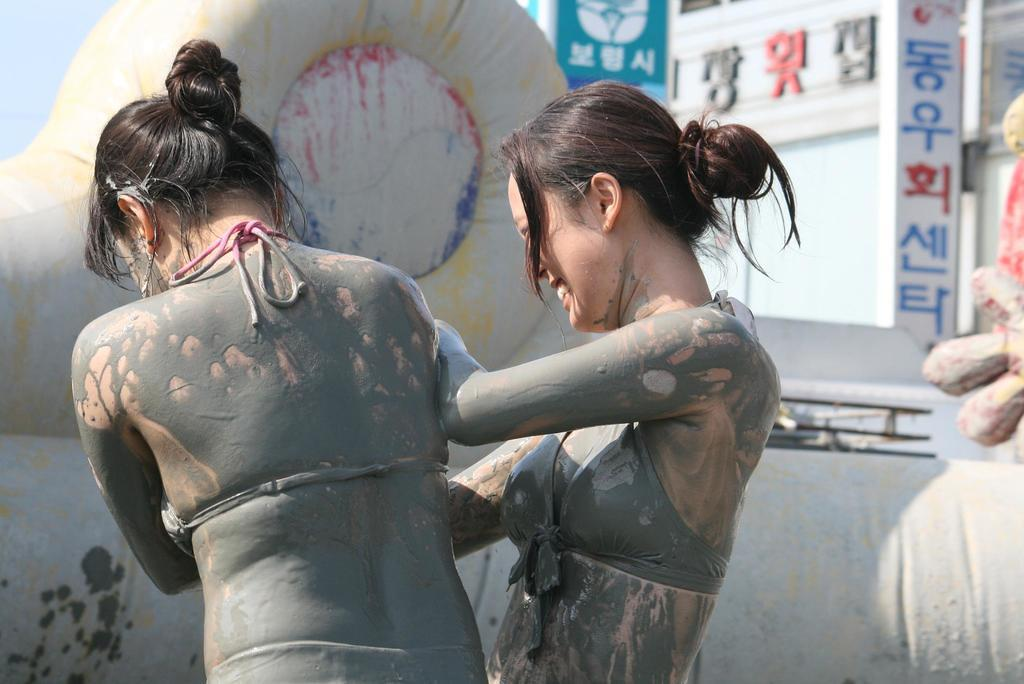How many people are the number of people in the image? There are two persons in the image. What can be seen in the background of the image? There is a wall and a name board in the background of the image. Are there any other objects visible in the background? Yes, there are other objects visible in the background of the image. Can you tell me how many hands the monkey has in the image? There is no monkey present in the image. Why are the two persons in the image crying? The provided facts do not mention any crying or emotional state of the persons in the image. 